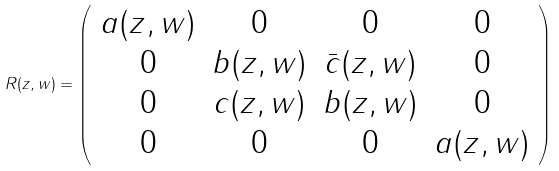Convert formula to latex. <formula><loc_0><loc_0><loc_500><loc_500>R ( z , w ) = \left ( \begin{array} { c c c c } a ( z , w ) & 0 & 0 & 0 \\ 0 & b ( z , w ) & \bar { c } ( z , w ) & 0 \\ 0 & c ( z , w ) & b ( z , w ) & 0 \\ 0 & 0 & 0 & a ( z , w ) \end{array} \right )</formula> 